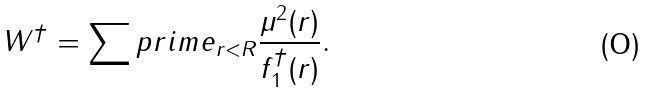<formula> <loc_0><loc_0><loc_500><loc_500>W ^ { \dagger } = \sum p r i m e _ { r < R } \frac { \mu ^ { 2 } ( r ) } { f _ { 1 } ^ { \dagger } ( r ) } .</formula> 